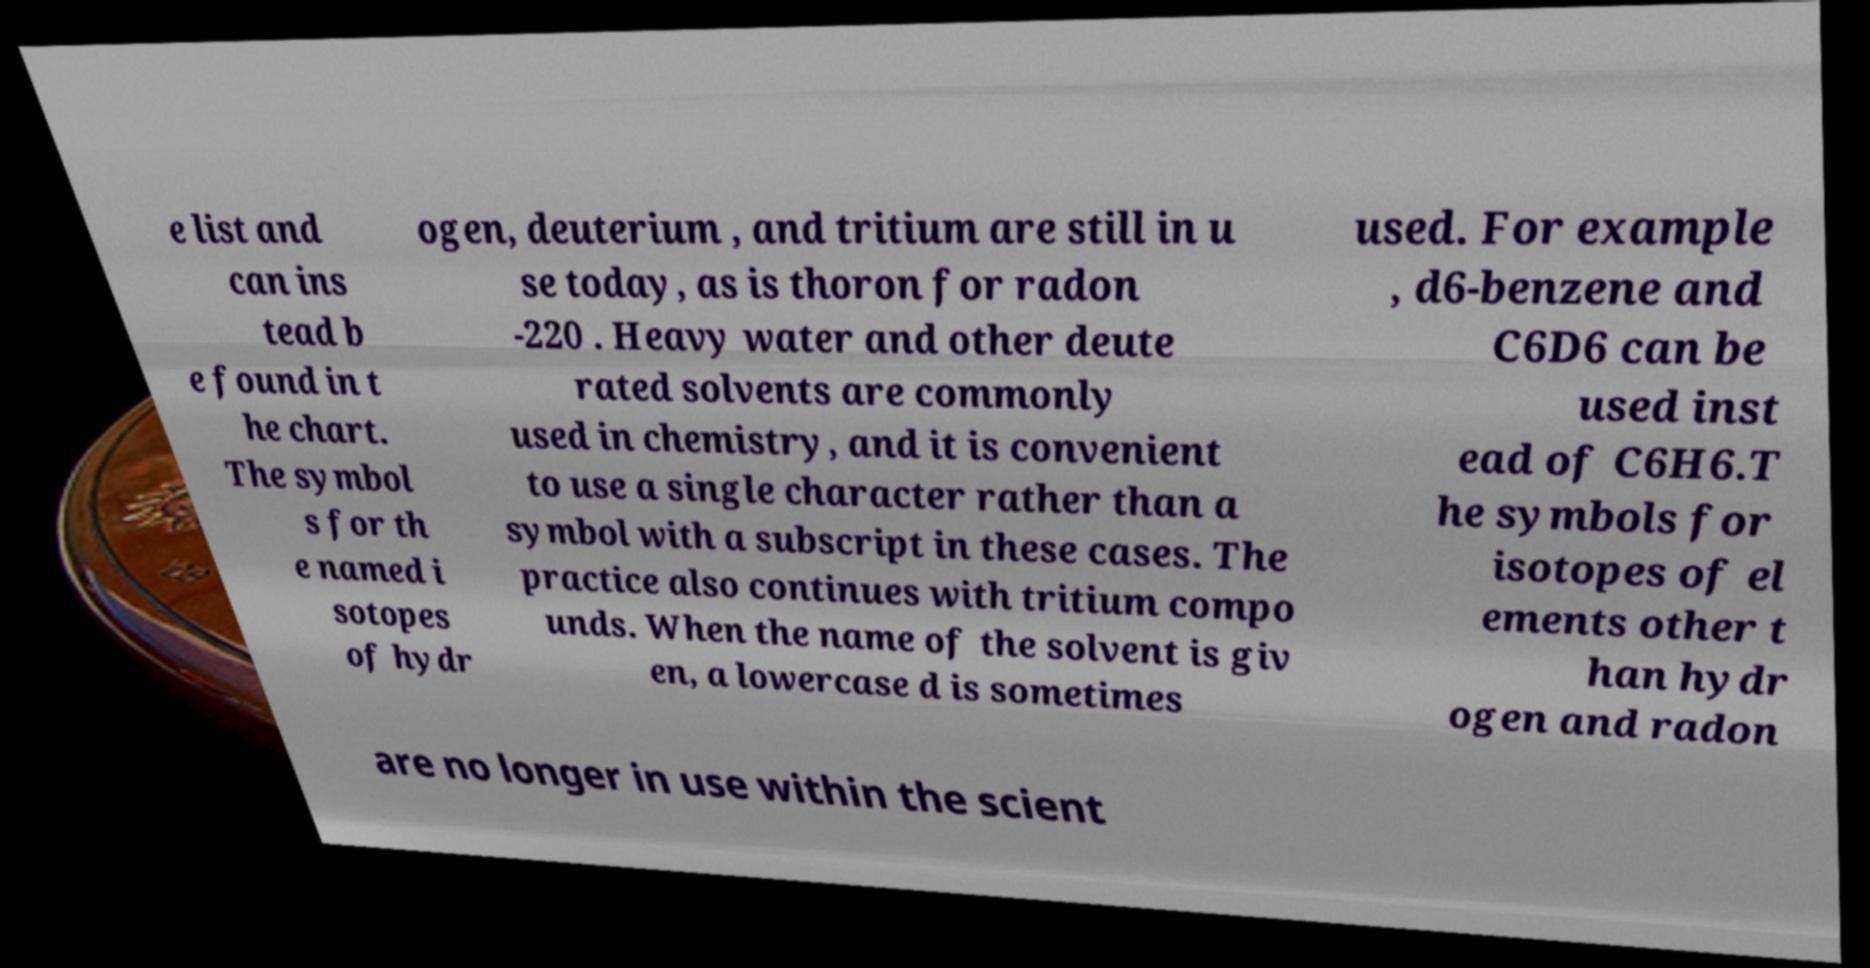Can you read and provide the text displayed in the image?This photo seems to have some interesting text. Can you extract and type it out for me? e list and can ins tead b e found in t he chart. The symbol s for th e named i sotopes of hydr ogen, deuterium , and tritium are still in u se today, as is thoron for radon -220 . Heavy water and other deute rated solvents are commonly used in chemistry, and it is convenient to use a single character rather than a symbol with a subscript in these cases. The practice also continues with tritium compo unds. When the name of the solvent is giv en, a lowercase d is sometimes used. For example , d6-benzene and C6D6 can be used inst ead of C6H6.T he symbols for isotopes of el ements other t han hydr ogen and radon are no longer in use within the scient 